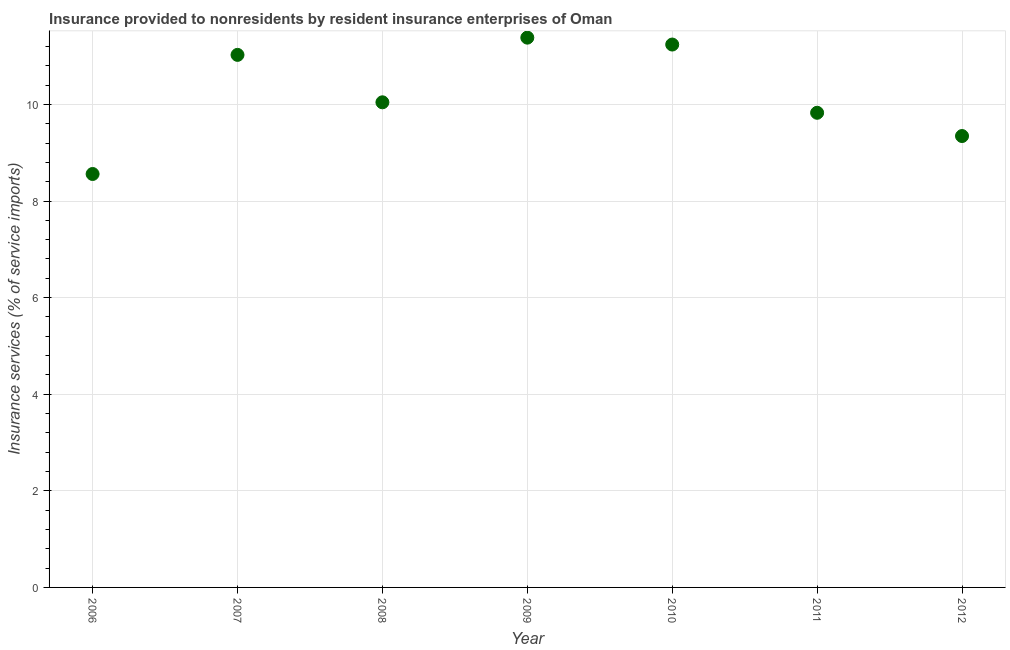What is the insurance and financial services in 2006?
Give a very brief answer. 8.56. Across all years, what is the maximum insurance and financial services?
Offer a very short reply. 11.38. Across all years, what is the minimum insurance and financial services?
Give a very brief answer. 8.56. What is the sum of the insurance and financial services?
Your answer should be very brief. 71.43. What is the difference between the insurance and financial services in 2007 and 2009?
Ensure brevity in your answer.  -0.36. What is the average insurance and financial services per year?
Offer a terse response. 10.2. What is the median insurance and financial services?
Provide a succinct answer. 10.04. In how many years, is the insurance and financial services greater than 1.6 %?
Provide a short and direct response. 7. Do a majority of the years between 2009 and 2006 (inclusive) have insurance and financial services greater than 8.4 %?
Keep it short and to the point. Yes. What is the ratio of the insurance and financial services in 2009 to that in 2012?
Your answer should be compact. 1.22. Is the insurance and financial services in 2006 less than that in 2008?
Your answer should be very brief. Yes. What is the difference between the highest and the second highest insurance and financial services?
Your answer should be compact. 0.14. What is the difference between the highest and the lowest insurance and financial services?
Keep it short and to the point. 2.82. How many dotlines are there?
Provide a succinct answer. 1. How many years are there in the graph?
Offer a very short reply. 7. What is the difference between two consecutive major ticks on the Y-axis?
Provide a succinct answer. 2. Are the values on the major ticks of Y-axis written in scientific E-notation?
Your response must be concise. No. Does the graph contain grids?
Keep it short and to the point. Yes. What is the title of the graph?
Give a very brief answer. Insurance provided to nonresidents by resident insurance enterprises of Oman. What is the label or title of the X-axis?
Your answer should be compact. Year. What is the label or title of the Y-axis?
Keep it short and to the point. Insurance services (% of service imports). What is the Insurance services (% of service imports) in 2006?
Offer a terse response. 8.56. What is the Insurance services (% of service imports) in 2007?
Offer a terse response. 11.03. What is the Insurance services (% of service imports) in 2008?
Provide a succinct answer. 10.04. What is the Insurance services (% of service imports) in 2009?
Your answer should be very brief. 11.38. What is the Insurance services (% of service imports) in 2010?
Provide a succinct answer. 11.24. What is the Insurance services (% of service imports) in 2011?
Keep it short and to the point. 9.83. What is the Insurance services (% of service imports) in 2012?
Your answer should be very brief. 9.35. What is the difference between the Insurance services (% of service imports) in 2006 and 2007?
Provide a succinct answer. -2.47. What is the difference between the Insurance services (% of service imports) in 2006 and 2008?
Give a very brief answer. -1.48. What is the difference between the Insurance services (% of service imports) in 2006 and 2009?
Offer a very short reply. -2.82. What is the difference between the Insurance services (% of service imports) in 2006 and 2010?
Keep it short and to the point. -2.68. What is the difference between the Insurance services (% of service imports) in 2006 and 2011?
Provide a short and direct response. -1.27. What is the difference between the Insurance services (% of service imports) in 2006 and 2012?
Make the answer very short. -0.79. What is the difference between the Insurance services (% of service imports) in 2007 and 2008?
Give a very brief answer. 0.98. What is the difference between the Insurance services (% of service imports) in 2007 and 2009?
Provide a succinct answer. -0.36. What is the difference between the Insurance services (% of service imports) in 2007 and 2010?
Offer a terse response. -0.21. What is the difference between the Insurance services (% of service imports) in 2007 and 2011?
Ensure brevity in your answer.  1.2. What is the difference between the Insurance services (% of service imports) in 2007 and 2012?
Keep it short and to the point. 1.68. What is the difference between the Insurance services (% of service imports) in 2008 and 2009?
Provide a short and direct response. -1.34. What is the difference between the Insurance services (% of service imports) in 2008 and 2010?
Provide a succinct answer. -1.2. What is the difference between the Insurance services (% of service imports) in 2008 and 2011?
Your response must be concise. 0.22. What is the difference between the Insurance services (% of service imports) in 2008 and 2012?
Provide a short and direct response. 0.7. What is the difference between the Insurance services (% of service imports) in 2009 and 2010?
Give a very brief answer. 0.14. What is the difference between the Insurance services (% of service imports) in 2009 and 2011?
Make the answer very short. 1.56. What is the difference between the Insurance services (% of service imports) in 2009 and 2012?
Provide a succinct answer. 2.04. What is the difference between the Insurance services (% of service imports) in 2010 and 2011?
Your answer should be compact. 1.41. What is the difference between the Insurance services (% of service imports) in 2010 and 2012?
Your answer should be compact. 1.89. What is the difference between the Insurance services (% of service imports) in 2011 and 2012?
Your answer should be very brief. 0.48. What is the ratio of the Insurance services (% of service imports) in 2006 to that in 2007?
Offer a terse response. 0.78. What is the ratio of the Insurance services (% of service imports) in 2006 to that in 2008?
Provide a succinct answer. 0.85. What is the ratio of the Insurance services (% of service imports) in 2006 to that in 2009?
Provide a short and direct response. 0.75. What is the ratio of the Insurance services (% of service imports) in 2006 to that in 2010?
Your response must be concise. 0.76. What is the ratio of the Insurance services (% of service imports) in 2006 to that in 2011?
Provide a succinct answer. 0.87. What is the ratio of the Insurance services (% of service imports) in 2006 to that in 2012?
Offer a terse response. 0.92. What is the ratio of the Insurance services (% of service imports) in 2007 to that in 2008?
Keep it short and to the point. 1.1. What is the ratio of the Insurance services (% of service imports) in 2007 to that in 2009?
Provide a short and direct response. 0.97. What is the ratio of the Insurance services (% of service imports) in 2007 to that in 2010?
Your answer should be very brief. 0.98. What is the ratio of the Insurance services (% of service imports) in 2007 to that in 2011?
Keep it short and to the point. 1.12. What is the ratio of the Insurance services (% of service imports) in 2007 to that in 2012?
Give a very brief answer. 1.18. What is the ratio of the Insurance services (% of service imports) in 2008 to that in 2009?
Make the answer very short. 0.88. What is the ratio of the Insurance services (% of service imports) in 2008 to that in 2010?
Give a very brief answer. 0.89. What is the ratio of the Insurance services (% of service imports) in 2008 to that in 2011?
Make the answer very short. 1.02. What is the ratio of the Insurance services (% of service imports) in 2008 to that in 2012?
Your response must be concise. 1.07. What is the ratio of the Insurance services (% of service imports) in 2009 to that in 2011?
Your answer should be compact. 1.16. What is the ratio of the Insurance services (% of service imports) in 2009 to that in 2012?
Your answer should be compact. 1.22. What is the ratio of the Insurance services (% of service imports) in 2010 to that in 2011?
Your answer should be compact. 1.14. What is the ratio of the Insurance services (% of service imports) in 2010 to that in 2012?
Offer a very short reply. 1.2. What is the ratio of the Insurance services (% of service imports) in 2011 to that in 2012?
Keep it short and to the point. 1.05. 